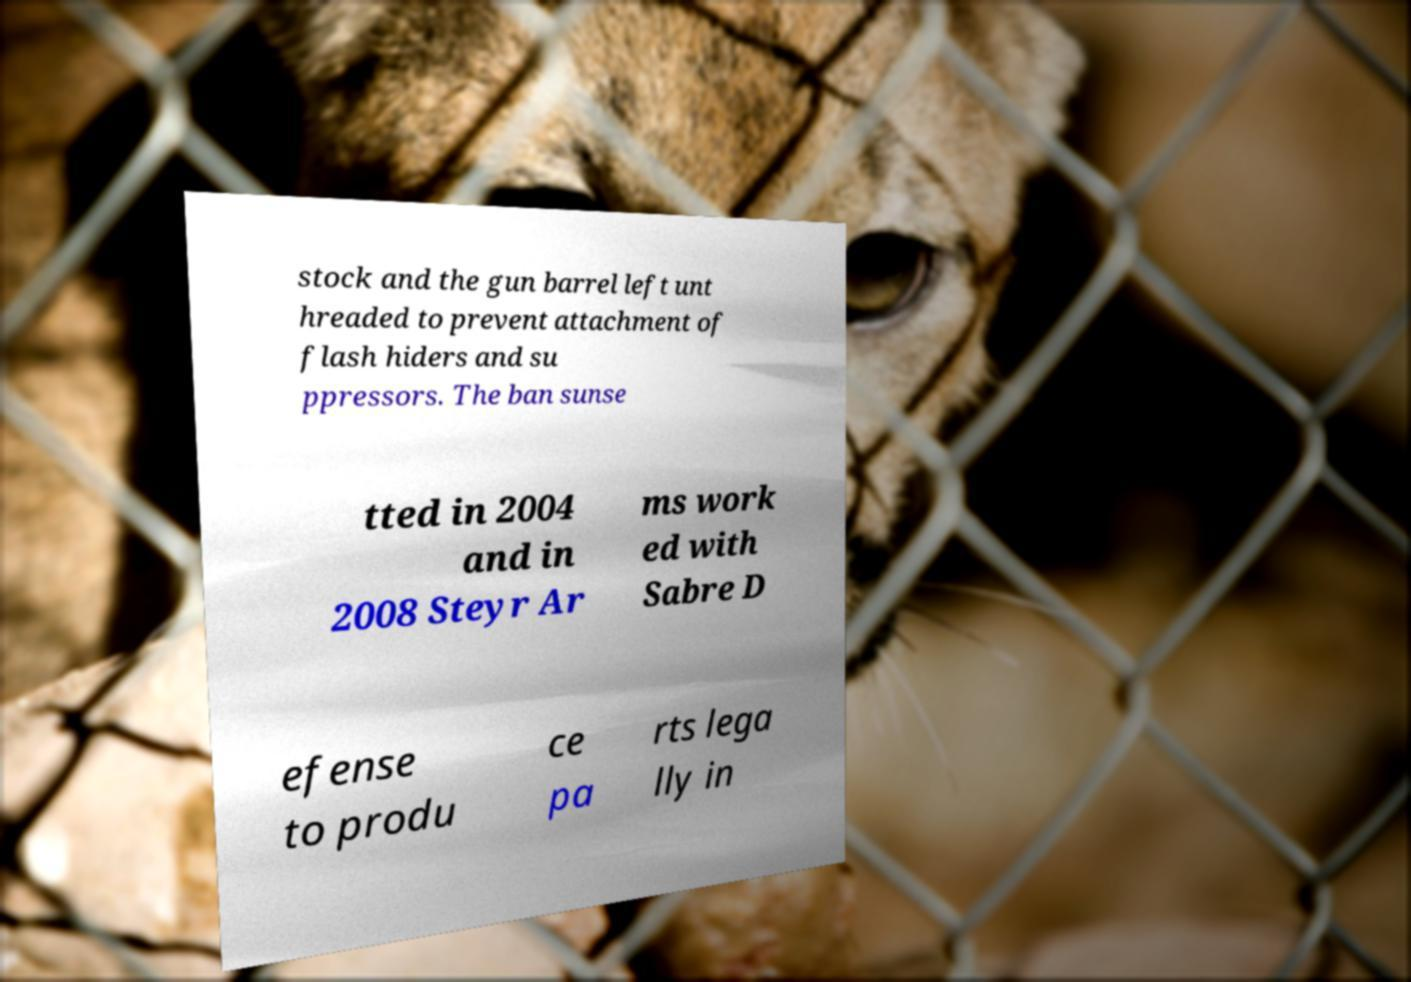What messages or text are displayed in this image? I need them in a readable, typed format. stock and the gun barrel left unt hreaded to prevent attachment of flash hiders and su ppressors. The ban sunse tted in 2004 and in 2008 Steyr Ar ms work ed with Sabre D efense to produ ce pa rts lega lly in 